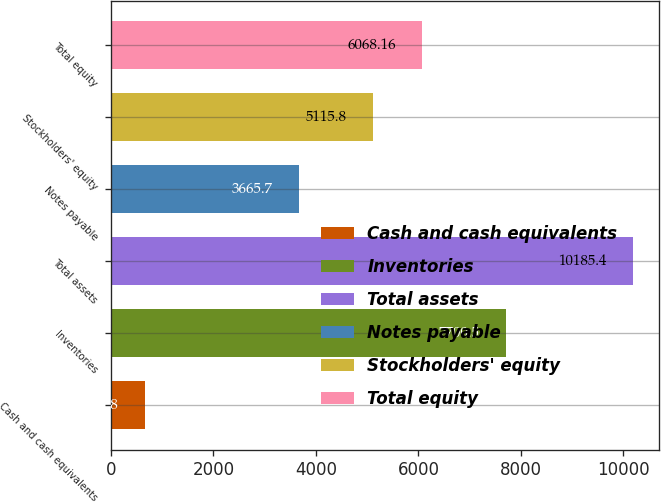Convert chart. <chart><loc_0><loc_0><loc_500><loc_500><bar_chart><fcel>Cash and cash equivalents<fcel>Inventories<fcel>Total assets<fcel>Notes payable<fcel>Stockholders' equity<fcel>Total equity<nl><fcel>661.8<fcel>7700.5<fcel>10185.4<fcel>3665.7<fcel>5115.8<fcel>6068.16<nl></chart> 